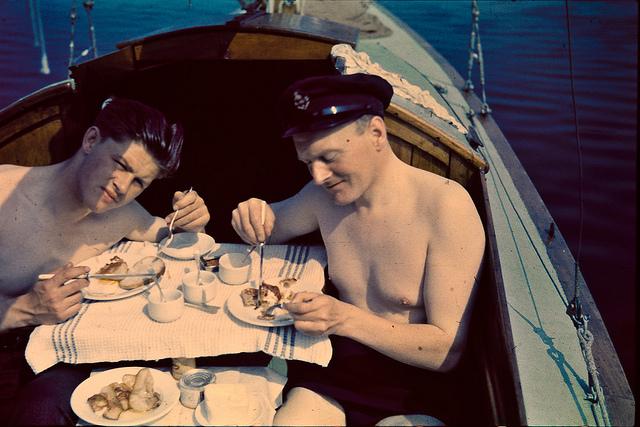Is the water calm?
Keep it brief. Yes. What are the men doing?
Write a very short answer. Eating. What are these men eating?
Be succinct. Fish. 